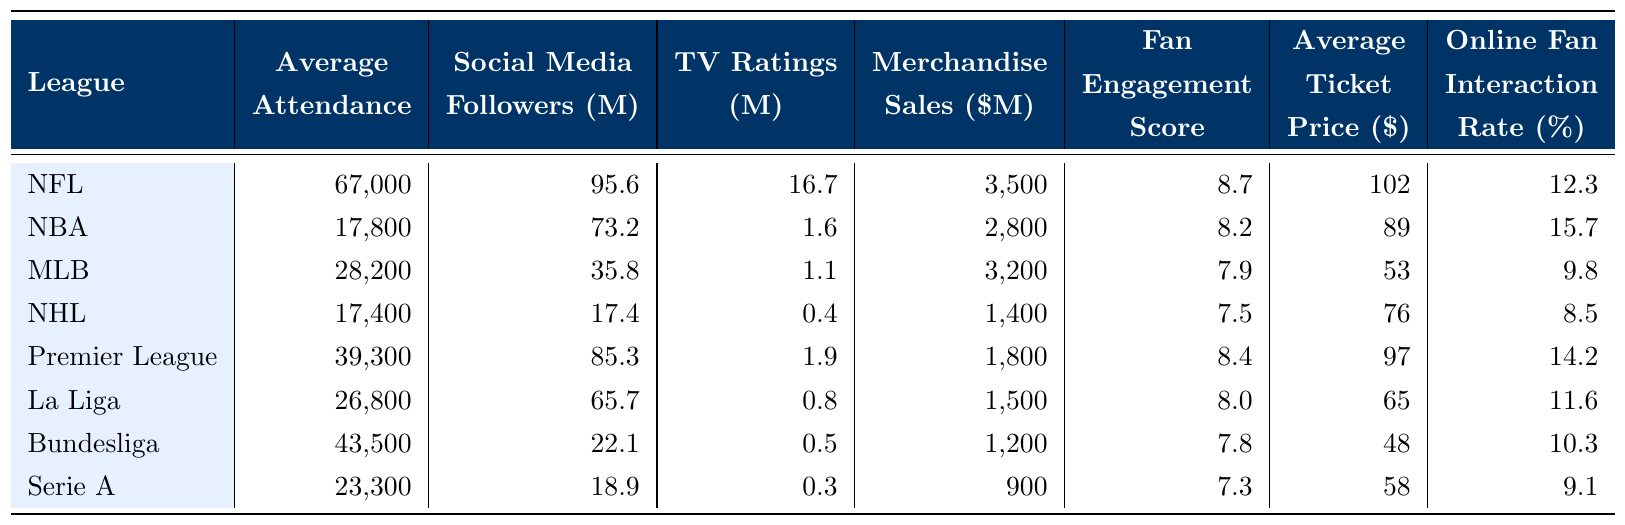What is the average attendance in the NFL? The table lists the average attendance for the NFL as 67,000.
Answer: 67,000 Which league has the highest number of social media followers? The NFL has the highest number of social media followers at 95.6 million, compared to other leagues.
Answer: NFL What is the merchandise sales figure for MLB? According to the table, MLB has merchandise sales of 3,200 million dollars.
Answer: 3,200 million Is the average ticket price higher in the NBA or the Premier League? The average ticket price for the NBA is 89 dollars, while for the Premier League it is 97 dollars, making the Premier League higher.
Answer: Premier League What is the difference in average attendance between the NFL and the NHL? The NFL's average attendance is 67,000 and the NHL's is 17,400. The difference is 67,000 - 17,400 = 49,600.
Answer: 49,600 Are the online fan interaction rates in Serie A and Bundesliga equal? The online fan interaction rate in Serie A is 9.1%, and in Bundesliga, it is 10.3%, so they are not equal.
Answer: No What's the average fan engagement score across all leagues? To calculate the average fan engagement score, sum all scores (8.7 + 8.2 + 7.9 + 7.5 + 8.4 + 8.0 + 7.8 + 7.3 = 64.8) and divide by the number of leagues (8), giving 64.8 / 8 = 8.1.
Answer: 8.1 Which league has the lowest TV ratings? The table shows that Serie A has the lowest TV ratings at 0.3 million, compared to the other leagues.
Answer: Serie A What is the total merchandise sales for NFL and MLB combined? To find this, add the merchandise sales for the NFL (3,500 million) and MLB (3,200 million), resulting in 3,500 + 3,200 = 6,700 million.
Answer: 6,700 million Do more fans attend games on average in La Liga than in NHL? Average attendance in La Liga is 26,800, while NHL has 17,400, which means La Liga has more.
Answer: Yes 